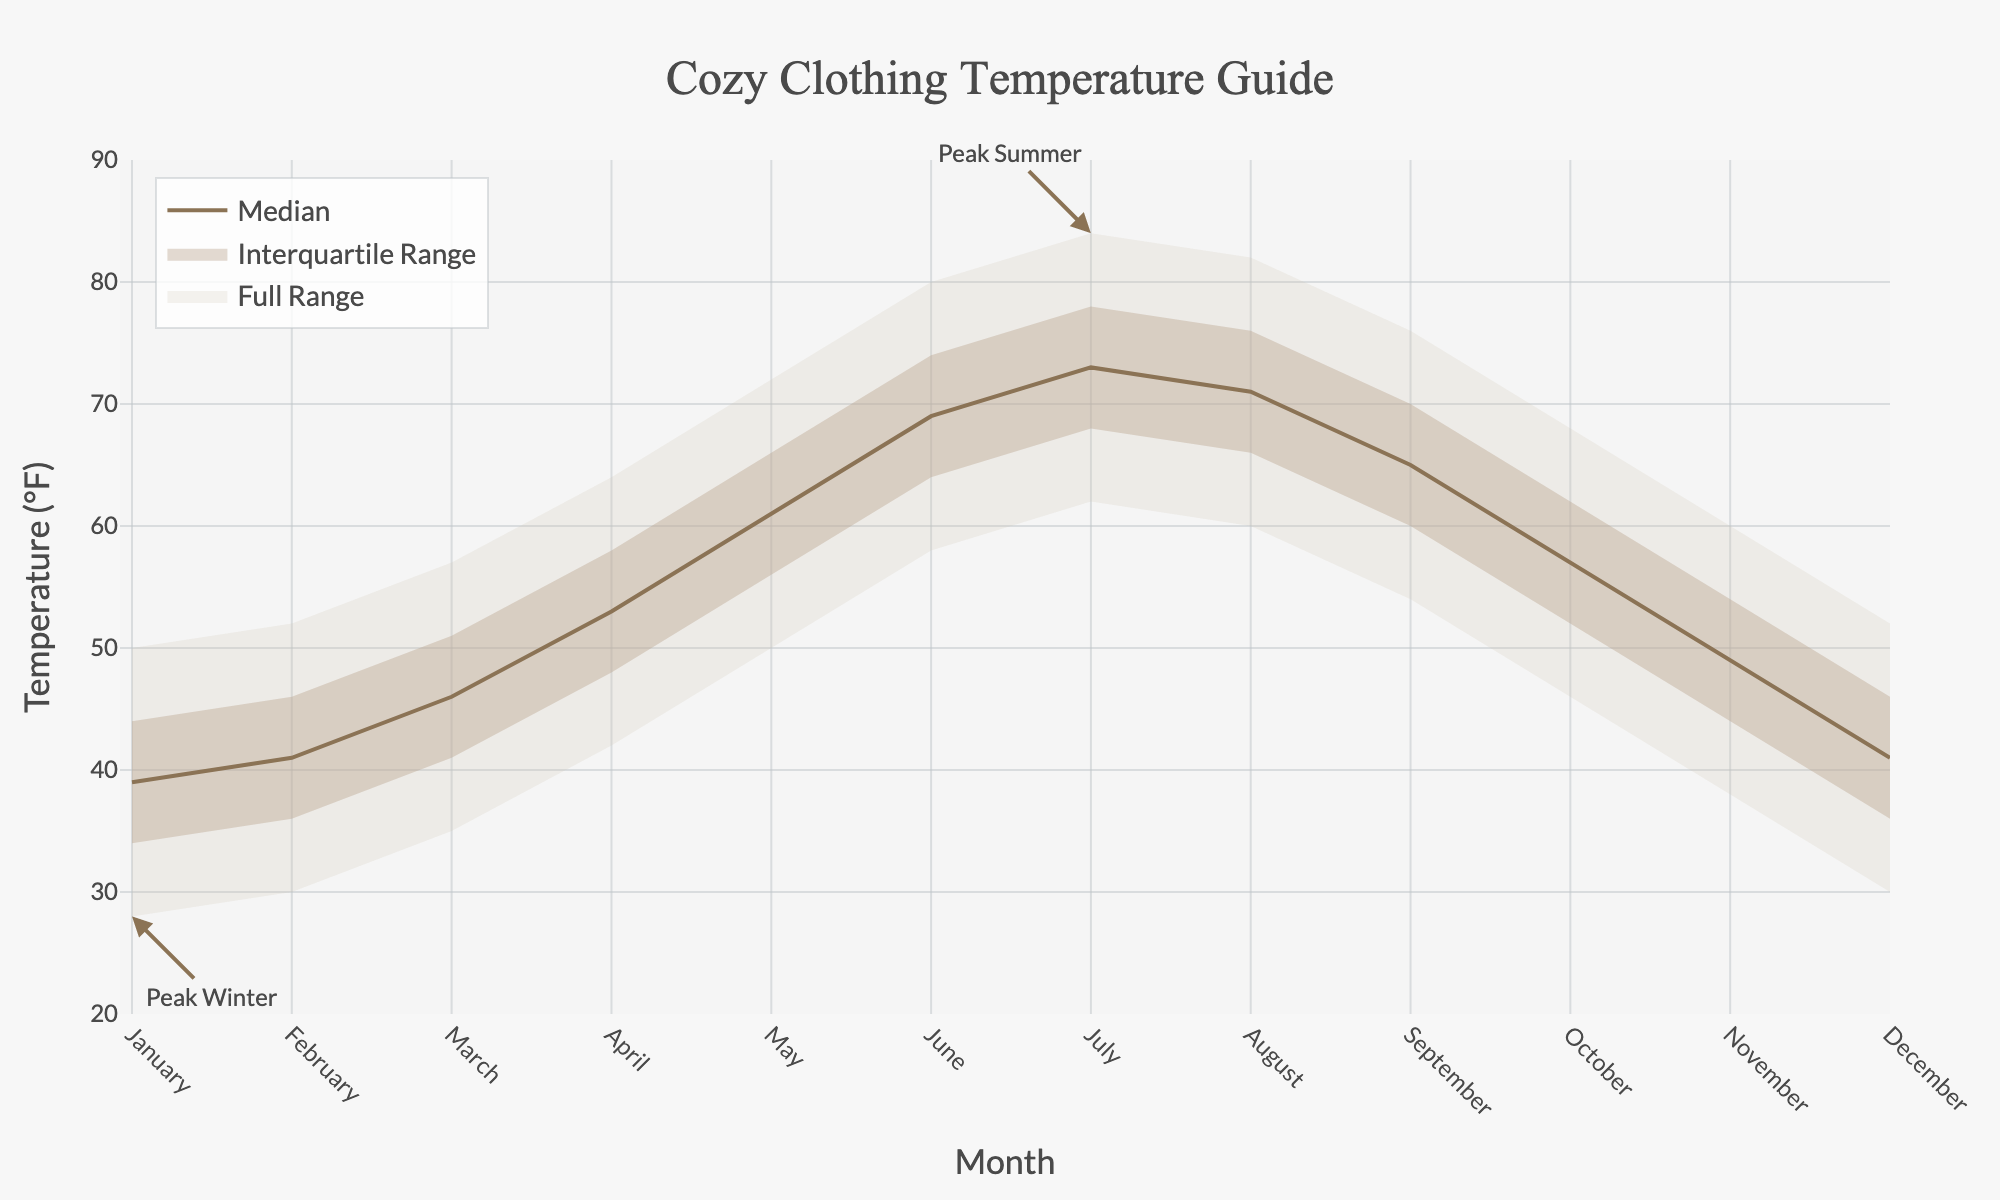What's the title of the chart? The title of the chart is usually displayed at the top of the figure. It reads "Cozy Clothing Temperature Guide".
Answer: Cozy Clothing Temperature Guide What temperature range is represented for the month of January? The temperature range for January can be found by looking at the range between the Low and High values on the y-axis corresponding to January on the x-axis. The Low is 28°F and the High is 50°F.
Answer: 28°F to 50°F What is the median temperature for April? The median temperature can be identified by finding the median line for April on the x-axis. According to the data, the median is 53°F.
Answer: 53°F In which month does the forecast predict the highest median temperature? The highest median temperature is found by comparing the median temperatures across all months. July shows the highest value with a median temperature of 73°F.
Answer: July What month shows the peak winter annotation? The annotation "Peak Winter" is marked on the chart around January. You can see an annotation pointing to the Low temperature for January.
Answer: January What is the temperature range for the Interquartile range in October? The interquartile range is between the 25th Percentile and the 75th Percentile. For October, the 25th Percentile is 52°F and the 75th Percentile is 62°F.
Answer: 52°F to 62°F How many temperature percentiles are displayed for each month? For each month, the chart displays five percentiles: Low, 25th Percentile, Median, 75th Percentile, and High.
Answer: Five Which month is indicated as the peak summer? The annotation "Peak Summer" is marked on the chart around July. You can see an annotation pointing to the High temperature for July.
Answer: July In which month is the interquartile range the narrowest? To find the narrowest interquartile range, look for the smallest difference between the 25th Percentile and the 75th Percentile values. For January, the 25th Percentile is 34°F and the 75th Percentile is 44°F, which is the narrowest interquartile range across all months.
Answer: January 